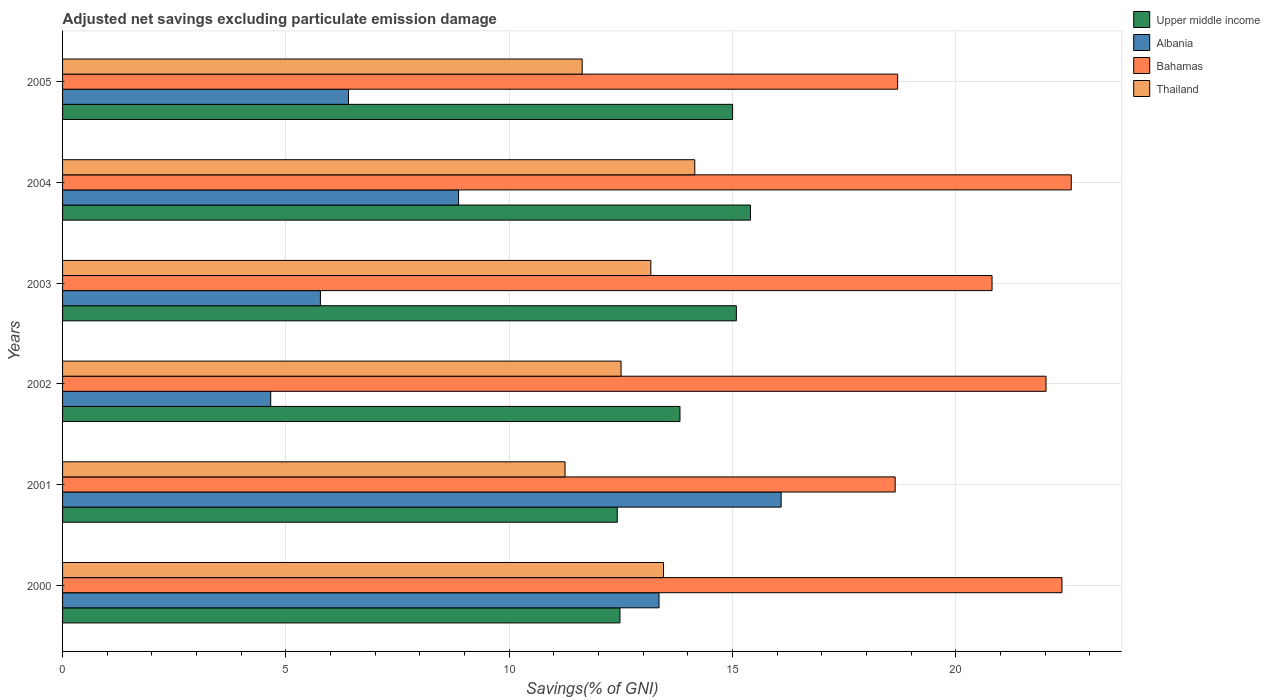How many groups of bars are there?
Offer a terse response. 6. How many bars are there on the 3rd tick from the top?
Ensure brevity in your answer.  4. What is the adjusted net savings in Upper middle income in 2002?
Your response must be concise. 13.82. Across all years, what is the maximum adjusted net savings in Thailand?
Provide a short and direct response. 14.16. Across all years, what is the minimum adjusted net savings in Upper middle income?
Give a very brief answer. 12.42. In which year was the adjusted net savings in Upper middle income maximum?
Your answer should be compact. 2004. What is the total adjusted net savings in Bahamas in the graph?
Give a very brief answer. 125.13. What is the difference between the adjusted net savings in Albania in 2000 and that in 2005?
Provide a succinct answer. 6.95. What is the difference between the adjusted net savings in Bahamas in 2000 and the adjusted net savings in Albania in 2002?
Give a very brief answer. 17.72. What is the average adjusted net savings in Bahamas per year?
Your answer should be compact. 20.86. In the year 2002, what is the difference between the adjusted net savings in Bahamas and adjusted net savings in Thailand?
Offer a terse response. 9.51. What is the ratio of the adjusted net savings in Thailand in 2002 to that in 2004?
Your answer should be compact. 0.88. Is the adjusted net savings in Thailand in 2000 less than that in 2003?
Make the answer very short. No. Is the difference between the adjusted net savings in Bahamas in 2001 and 2005 greater than the difference between the adjusted net savings in Thailand in 2001 and 2005?
Give a very brief answer. Yes. What is the difference between the highest and the second highest adjusted net savings in Thailand?
Ensure brevity in your answer.  0.7. What is the difference between the highest and the lowest adjusted net savings in Albania?
Give a very brief answer. 11.43. What does the 2nd bar from the top in 2003 represents?
Your response must be concise. Bahamas. What does the 3rd bar from the bottom in 2003 represents?
Offer a terse response. Bahamas. How many years are there in the graph?
Your answer should be very brief. 6. How many legend labels are there?
Offer a very short reply. 4. What is the title of the graph?
Keep it short and to the point. Adjusted net savings excluding particulate emission damage. What is the label or title of the X-axis?
Ensure brevity in your answer.  Savings(% of GNI). What is the label or title of the Y-axis?
Keep it short and to the point. Years. What is the Savings(% of GNI) in Upper middle income in 2000?
Make the answer very short. 12.48. What is the Savings(% of GNI) of Albania in 2000?
Your response must be concise. 13.35. What is the Savings(% of GNI) of Bahamas in 2000?
Give a very brief answer. 22.38. What is the Savings(% of GNI) of Thailand in 2000?
Make the answer very short. 13.46. What is the Savings(% of GNI) of Upper middle income in 2001?
Make the answer very short. 12.42. What is the Savings(% of GNI) in Albania in 2001?
Keep it short and to the point. 16.09. What is the Savings(% of GNI) in Bahamas in 2001?
Your response must be concise. 18.64. What is the Savings(% of GNI) of Thailand in 2001?
Your answer should be very brief. 11.25. What is the Savings(% of GNI) of Upper middle income in 2002?
Make the answer very short. 13.82. What is the Savings(% of GNI) in Albania in 2002?
Provide a succinct answer. 4.66. What is the Savings(% of GNI) of Bahamas in 2002?
Keep it short and to the point. 22.02. What is the Savings(% of GNI) of Thailand in 2002?
Offer a very short reply. 12.51. What is the Savings(% of GNI) in Upper middle income in 2003?
Offer a very short reply. 15.09. What is the Savings(% of GNI) of Albania in 2003?
Keep it short and to the point. 5.77. What is the Savings(% of GNI) of Bahamas in 2003?
Ensure brevity in your answer.  20.81. What is the Savings(% of GNI) of Thailand in 2003?
Your answer should be compact. 13.17. What is the Savings(% of GNI) in Upper middle income in 2004?
Make the answer very short. 15.4. What is the Savings(% of GNI) in Albania in 2004?
Provide a succinct answer. 8.87. What is the Savings(% of GNI) of Bahamas in 2004?
Give a very brief answer. 22.58. What is the Savings(% of GNI) in Thailand in 2004?
Your response must be concise. 14.16. What is the Savings(% of GNI) in Upper middle income in 2005?
Provide a short and direct response. 15. What is the Savings(% of GNI) of Albania in 2005?
Make the answer very short. 6.4. What is the Savings(% of GNI) of Bahamas in 2005?
Keep it short and to the point. 18.7. What is the Savings(% of GNI) of Thailand in 2005?
Your response must be concise. 11.63. Across all years, what is the maximum Savings(% of GNI) in Upper middle income?
Offer a terse response. 15.4. Across all years, what is the maximum Savings(% of GNI) in Albania?
Give a very brief answer. 16.09. Across all years, what is the maximum Savings(% of GNI) in Bahamas?
Ensure brevity in your answer.  22.58. Across all years, what is the maximum Savings(% of GNI) of Thailand?
Your response must be concise. 14.16. Across all years, what is the minimum Savings(% of GNI) of Upper middle income?
Provide a succinct answer. 12.42. Across all years, what is the minimum Savings(% of GNI) in Albania?
Give a very brief answer. 4.66. Across all years, what is the minimum Savings(% of GNI) in Bahamas?
Provide a succinct answer. 18.64. Across all years, what is the minimum Savings(% of GNI) in Thailand?
Provide a short and direct response. 11.25. What is the total Savings(% of GNI) of Upper middle income in the graph?
Provide a succinct answer. 84.21. What is the total Savings(% of GNI) in Albania in the graph?
Make the answer very short. 55.15. What is the total Savings(% of GNI) of Bahamas in the graph?
Give a very brief answer. 125.13. What is the total Savings(% of GNI) of Thailand in the graph?
Offer a very short reply. 76.17. What is the difference between the Savings(% of GNI) in Upper middle income in 2000 and that in 2001?
Make the answer very short. 0.06. What is the difference between the Savings(% of GNI) of Albania in 2000 and that in 2001?
Your answer should be compact. -2.73. What is the difference between the Savings(% of GNI) in Bahamas in 2000 and that in 2001?
Ensure brevity in your answer.  3.73. What is the difference between the Savings(% of GNI) of Thailand in 2000 and that in 2001?
Ensure brevity in your answer.  2.21. What is the difference between the Savings(% of GNI) of Upper middle income in 2000 and that in 2002?
Ensure brevity in your answer.  -1.34. What is the difference between the Savings(% of GNI) in Albania in 2000 and that in 2002?
Your answer should be very brief. 8.69. What is the difference between the Savings(% of GNI) in Bahamas in 2000 and that in 2002?
Your answer should be compact. 0.36. What is the difference between the Savings(% of GNI) of Thailand in 2000 and that in 2002?
Ensure brevity in your answer.  0.95. What is the difference between the Savings(% of GNI) in Upper middle income in 2000 and that in 2003?
Provide a succinct answer. -2.61. What is the difference between the Savings(% of GNI) in Albania in 2000 and that in 2003?
Make the answer very short. 7.58. What is the difference between the Savings(% of GNI) of Bahamas in 2000 and that in 2003?
Your answer should be compact. 1.57. What is the difference between the Savings(% of GNI) of Thailand in 2000 and that in 2003?
Your answer should be very brief. 0.28. What is the difference between the Savings(% of GNI) of Upper middle income in 2000 and that in 2004?
Provide a succinct answer. -2.92. What is the difference between the Savings(% of GNI) in Albania in 2000 and that in 2004?
Ensure brevity in your answer.  4.49. What is the difference between the Savings(% of GNI) of Bahamas in 2000 and that in 2004?
Keep it short and to the point. -0.21. What is the difference between the Savings(% of GNI) in Thailand in 2000 and that in 2004?
Offer a terse response. -0.7. What is the difference between the Savings(% of GNI) of Upper middle income in 2000 and that in 2005?
Provide a succinct answer. -2.52. What is the difference between the Savings(% of GNI) in Albania in 2000 and that in 2005?
Your answer should be very brief. 6.95. What is the difference between the Savings(% of GNI) in Bahamas in 2000 and that in 2005?
Give a very brief answer. 3.68. What is the difference between the Savings(% of GNI) of Thailand in 2000 and that in 2005?
Your answer should be very brief. 1.82. What is the difference between the Savings(% of GNI) of Upper middle income in 2001 and that in 2002?
Your answer should be very brief. -1.4. What is the difference between the Savings(% of GNI) in Albania in 2001 and that in 2002?
Ensure brevity in your answer.  11.43. What is the difference between the Savings(% of GNI) of Bahamas in 2001 and that in 2002?
Provide a succinct answer. -3.38. What is the difference between the Savings(% of GNI) of Thailand in 2001 and that in 2002?
Offer a terse response. -1.26. What is the difference between the Savings(% of GNI) of Upper middle income in 2001 and that in 2003?
Offer a very short reply. -2.67. What is the difference between the Savings(% of GNI) in Albania in 2001 and that in 2003?
Ensure brevity in your answer.  10.32. What is the difference between the Savings(% of GNI) in Bahamas in 2001 and that in 2003?
Provide a succinct answer. -2.17. What is the difference between the Savings(% of GNI) in Thailand in 2001 and that in 2003?
Your answer should be very brief. -1.92. What is the difference between the Savings(% of GNI) of Upper middle income in 2001 and that in 2004?
Your answer should be very brief. -2.98. What is the difference between the Savings(% of GNI) in Albania in 2001 and that in 2004?
Your response must be concise. 7.22. What is the difference between the Savings(% of GNI) in Bahamas in 2001 and that in 2004?
Your response must be concise. -3.94. What is the difference between the Savings(% of GNI) of Thailand in 2001 and that in 2004?
Your response must be concise. -2.9. What is the difference between the Savings(% of GNI) in Upper middle income in 2001 and that in 2005?
Make the answer very short. -2.58. What is the difference between the Savings(% of GNI) in Albania in 2001 and that in 2005?
Your answer should be compact. 9.69. What is the difference between the Savings(% of GNI) in Bahamas in 2001 and that in 2005?
Give a very brief answer. -0.06. What is the difference between the Savings(% of GNI) in Thailand in 2001 and that in 2005?
Ensure brevity in your answer.  -0.38. What is the difference between the Savings(% of GNI) in Upper middle income in 2002 and that in 2003?
Make the answer very short. -1.26. What is the difference between the Savings(% of GNI) in Albania in 2002 and that in 2003?
Your response must be concise. -1.11. What is the difference between the Savings(% of GNI) in Bahamas in 2002 and that in 2003?
Ensure brevity in your answer.  1.21. What is the difference between the Savings(% of GNI) in Thailand in 2002 and that in 2003?
Make the answer very short. -0.67. What is the difference between the Savings(% of GNI) of Upper middle income in 2002 and that in 2004?
Offer a terse response. -1.58. What is the difference between the Savings(% of GNI) in Albania in 2002 and that in 2004?
Your answer should be compact. -4.21. What is the difference between the Savings(% of GNI) of Bahamas in 2002 and that in 2004?
Keep it short and to the point. -0.56. What is the difference between the Savings(% of GNI) in Thailand in 2002 and that in 2004?
Give a very brief answer. -1.65. What is the difference between the Savings(% of GNI) in Upper middle income in 2002 and that in 2005?
Give a very brief answer. -1.18. What is the difference between the Savings(% of GNI) in Albania in 2002 and that in 2005?
Your answer should be compact. -1.74. What is the difference between the Savings(% of GNI) of Bahamas in 2002 and that in 2005?
Make the answer very short. 3.32. What is the difference between the Savings(% of GNI) in Thailand in 2002 and that in 2005?
Ensure brevity in your answer.  0.87. What is the difference between the Savings(% of GNI) in Upper middle income in 2003 and that in 2004?
Provide a short and direct response. -0.32. What is the difference between the Savings(% of GNI) in Albania in 2003 and that in 2004?
Keep it short and to the point. -3.09. What is the difference between the Savings(% of GNI) in Bahamas in 2003 and that in 2004?
Provide a succinct answer. -1.77. What is the difference between the Savings(% of GNI) of Thailand in 2003 and that in 2004?
Offer a terse response. -0.98. What is the difference between the Savings(% of GNI) in Upper middle income in 2003 and that in 2005?
Provide a succinct answer. 0.08. What is the difference between the Savings(% of GNI) in Albania in 2003 and that in 2005?
Offer a terse response. -0.63. What is the difference between the Savings(% of GNI) of Bahamas in 2003 and that in 2005?
Provide a short and direct response. 2.11. What is the difference between the Savings(% of GNI) of Thailand in 2003 and that in 2005?
Your answer should be very brief. 1.54. What is the difference between the Savings(% of GNI) in Upper middle income in 2004 and that in 2005?
Your answer should be compact. 0.4. What is the difference between the Savings(% of GNI) in Albania in 2004 and that in 2005?
Make the answer very short. 2.47. What is the difference between the Savings(% of GNI) of Bahamas in 2004 and that in 2005?
Keep it short and to the point. 3.89. What is the difference between the Savings(% of GNI) in Thailand in 2004 and that in 2005?
Give a very brief answer. 2.52. What is the difference between the Savings(% of GNI) in Upper middle income in 2000 and the Savings(% of GNI) in Albania in 2001?
Your response must be concise. -3.61. What is the difference between the Savings(% of GNI) of Upper middle income in 2000 and the Savings(% of GNI) of Bahamas in 2001?
Your response must be concise. -6.16. What is the difference between the Savings(% of GNI) of Upper middle income in 2000 and the Savings(% of GNI) of Thailand in 2001?
Offer a terse response. 1.23. What is the difference between the Savings(% of GNI) in Albania in 2000 and the Savings(% of GNI) in Bahamas in 2001?
Provide a succinct answer. -5.29. What is the difference between the Savings(% of GNI) in Albania in 2000 and the Savings(% of GNI) in Thailand in 2001?
Give a very brief answer. 2.1. What is the difference between the Savings(% of GNI) in Bahamas in 2000 and the Savings(% of GNI) in Thailand in 2001?
Keep it short and to the point. 11.13. What is the difference between the Savings(% of GNI) in Upper middle income in 2000 and the Savings(% of GNI) in Albania in 2002?
Keep it short and to the point. 7.82. What is the difference between the Savings(% of GNI) in Upper middle income in 2000 and the Savings(% of GNI) in Bahamas in 2002?
Make the answer very short. -9.54. What is the difference between the Savings(% of GNI) of Upper middle income in 2000 and the Savings(% of GNI) of Thailand in 2002?
Ensure brevity in your answer.  -0.03. What is the difference between the Savings(% of GNI) in Albania in 2000 and the Savings(% of GNI) in Bahamas in 2002?
Your answer should be very brief. -8.67. What is the difference between the Savings(% of GNI) in Albania in 2000 and the Savings(% of GNI) in Thailand in 2002?
Keep it short and to the point. 0.85. What is the difference between the Savings(% of GNI) in Bahamas in 2000 and the Savings(% of GNI) in Thailand in 2002?
Your response must be concise. 9.87. What is the difference between the Savings(% of GNI) of Upper middle income in 2000 and the Savings(% of GNI) of Albania in 2003?
Provide a short and direct response. 6.71. What is the difference between the Savings(% of GNI) of Upper middle income in 2000 and the Savings(% of GNI) of Bahamas in 2003?
Ensure brevity in your answer.  -8.33. What is the difference between the Savings(% of GNI) of Upper middle income in 2000 and the Savings(% of GNI) of Thailand in 2003?
Ensure brevity in your answer.  -0.69. What is the difference between the Savings(% of GNI) in Albania in 2000 and the Savings(% of GNI) in Bahamas in 2003?
Your answer should be very brief. -7.46. What is the difference between the Savings(% of GNI) of Albania in 2000 and the Savings(% of GNI) of Thailand in 2003?
Make the answer very short. 0.18. What is the difference between the Savings(% of GNI) in Bahamas in 2000 and the Savings(% of GNI) in Thailand in 2003?
Give a very brief answer. 9.21. What is the difference between the Savings(% of GNI) in Upper middle income in 2000 and the Savings(% of GNI) in Albania in 2004?
Your answer should be compact. 3.61. What is the difference between the Savings(% of GNI) of Upper middle income in 2000 and the Savings(% of GNI) of Bahamas in 2004?
Provide a short and direct response. -10.11. What is the difference between the Savings(% of GNI) of Upper middle income in 2000 and the Savings(% of GNI) of Thailand in 2004?
Give a very brief answer. -1.68. What is the difference between the Savings(% of GNI) of Albania in 2000 and the Savings(% of GNI) of Bahamas in 2004?
Offer a terse response. -9.23. What is the difference between the Savings(% of GNI) in Albania in 2000 and the Savings(% of GNI) in Thailand in 2004?
Make the answer very short. -0.8. What is the difference between the Savings(% of GNI) of Bahamas in 2000 and the Savings(% of GNI) of Thailand in 2004?
Your answer should be very brief. 8.22. What is the difference between the Savings(% of GNI) in Upper middle income in 2000 and the Savings(% of GNI) in Albania in 2005?
Keep it short and to the point. 6.08. What is the difference between the Savings(% of GNI) in Upper middle income in 2000 and the Savings(% of GNI) in Bahamas in 2005?
Your answer should be compact. -6.22. What is the difference between the Savings(% of GNI) of Upper middle income in 2000 and the Savings(% of GNI) of Thailand in 2005?
Give a very brief answer. 0.85. What is the difference between the Savings(% of GNI) in Albania in 2000 and the Savings(% of GNI) in Bahamas in 2005?
Offer a terse response. -5.34. What is the difference between the Savings(% of GNI) in Albania in 2000 and the Savings(% of GNI) in Thailand in 2005?
Your answer should be compact. 1.72. What is the difference between the Savings(% of GNI) of Bahamas in 2000 and the Savings(% of GNI) of Thailand in 2005?
Keep it short and to the point. 10.74. What is the difference between the Savings(% of GNI) of Upper middle income in 2001 and the Savings(% of GNI) of Albania in 2002?
Offer a terse response. 7.76. What is the difference between the Savings(% of GNI) of Upper middle income in 2001 and the Savings(% of GNI) of Bahamas in 2002?
Keep it short and to the point. -9.6. What is the difference between the Savings(% of GNI) of Upper middle income in 2001 and the Savings(% of GNI) of Thailand in 2002?
Give a very brief answer. -0.09. What is the difference between the Savings(% of GNI) in Albania in 2001 and the Savings(% of GNI) in Bahamas in 2002?
Give a very brief answer. -5.93. What is the difference between the Savings(% of GNI) in Albania in 2001 and the Savings(% of GNI) in Thailand in 2002?
Offer a very short reply. 3.58. What is the difference between the Savings(% of GNI) in Bahamas in 2001 and the Savings(% of GNI) in Thailand in 2002?
Give a very brief answer. 6.14. What is the difference between the Savings(% of GNI) in Upper middle income in 2001 and the Savings(% of GNI) in Albania in 2003?
Your answer should be compact. 6.65. What is the difference between the Savings(% of GNI) of Upper middle income in 2001 and the Savings(% of GNI) of Bahamas in 2003?
Give a very brief answer. -8.39. What is the difference between the Savings(% of GNI) of Upper middle income in 2001 and the Savings(% of GNI) of Thailand in 2003?
Your answer should be very brief. -0.75. What is the difference between the Savings(% of GNI) of Albania in 2001 and the Savings(% of GNI) of Bahamas in 2003?
Your response must be concise. -4.72. What is the difference between the Savings(% of GNI) in Albania in 2001 and the Savings(% of GNI) in Thailand in 2003?
Provide a short and direct response. 2.92. What is the difference between the Savings(% of GNI) in Bahamas in 2001 and the Savings(% of GNI) in Thailand in 2003?
Offer a terse response. 5.47. What is the difference between the Savings(% of GNI) in Upper middle income in 2001 and the Savings(% of GNI) in Albania in 2004?
Make the answer very short. 3.55. What is the difference between the Savings(% of GNI) in Upper middle income in 2001 and the Savings(% of GNI) in Bahamas in 2004?
Your answer should be compact. -10.17. What is the difference between the Savings(% of GNI) of Upper middle income in 2001 and the Savings(% of GNI) of Thailand in 2004?
Make the answer very short. -1.74. What is the difference between the Savings(% of GNI) of Albania in 2001 and the Savings(% of GNI) of Bahamas in 2004?
Your answer should be very brief. -6.5. What is the difference between the Savings(% of GNI) of Albania in 2001 and the Savings(% of GNI) of Thailand in 2004?
Ensure brevity in your answer.  1.93. What is the difference between the Savings(% of GNI) in Bahamas in 2001 and the Savings(% of GNI) in Thailand in 2004?
Your answer should be compact. 4.49. What is the difference between the Savings(% of GNI) of Upper middle income in 2001 and the Savings(% of GNI) of Albania in 2005?
Keep it short and to the point. 6.02. What is the difference between the Savings(% of GNI) in Upper middle income in 2001 and the Savings(% of GNI) in Bahamas in 2005?
Provide a short and direct response. -6.28. What is the difference between the Savings(% of GNI) of Upper middle income in 2001 and the Savings(% of GNI) of Thailand in 2005?
Your answer should be very brief. 0.79. What is the difference between the Savings(% of GNI) of Albania in 2001 and the Savings(% of GNI) of Bahamas in 2005?
Your answer should be compact. -2.61. What is the difference between the Savings(% of GNI) in Albania in 2001 and the Savings(% of GNI) in Thailand in 2005?
Offer a very short reply. 4.45. What is the difference between the Savings(% of GNI) of Bahamas in 2001 and the Savings(% of GNI) of Thailand in 2005?
Give a very brief answer. 7.01. What is the difference between the Savings(% of GNI) of Upper middle income in 2002 and the Savings(% of GNI) of Albania in 2003?
Ensure brevity in your answer.  8.05. What is the difference between the Savings(% of GNI) of Upper middle income in 2002 and the Savings(% of GNI) of Bahamas in 2003?
Keep it short and to the point. -6.99. What is the difference between the Savings(% of GNI) of Upper middle income in 2002 and the Savings(% of GNI) of Thailand in 2003?
Your answer should be compact. 0.65. What is the difference between the Savings(% of GNI) of Albania in 2002 and the Savings(% of GNI) of Bahamas in 2003?
Your response must be concise. -16.15. What is the difference between the Savings(% of GNI) in Albania in 2002 and the Savings(% of GNI) in Thailand in 2003?
Provide a succinct answer. -8.51. What is the difference between the Savings(% of GNI) of Bahamas in 2002 and the Savings(% of GNI) of Thailand in 2003?
Make the answer very short. 8.85. What is the difference between the Savings(% of GNI) of Upper middle income in 2002 and the Savings(% of GNI) of Albania in 2004?
Provide a short and direct response. 4.96. What is the difference between the Savings(% of GNI) in Upper middle income in 2002 and the Savings(% of GNI) in Bahamas in 2004?
Your response must be concise. -8.76. What is the difference between the Savings(% of GNI) of Upper middle income in 2002 and the Savings(% of GNI) of Thailand in 2004?
Offer a terse response. -0.33. What is the difference between the Savings(% of GNI) in Albania in 2002 and the Savings(% of GNI) in Bahamas in 2004?
Ensure brevity in your answer.  -17.92. What is the difference between the Savings(% of GNI) of Albania in 2002 and the Savings(% of GNI) of Thailand in 2004?
Your response must be concise. -9.49. What is the difference between the Savings(% of GNI) of Bahamas in 2002 and the Savings(% of GNI) of Thailand in 2004?
Ensure brevity in your answer.  7.87. What is the difference between the Savings(% of GNI) in Upper middle income in 2002 and the Savings(% of GNI) in Albania in 2005?
Give a very brief answer. 7.42. What is the difference between the Savings(% of GNI) of Upper middle income in 2002 and the Savings(% of GNI) of Bahamas in 2005?
Your answer should be compact. -4.87. What is the difference between the Savings(% of GNI) of Upper middle income in 2002 and the Savings(% of GNI) of Thailand in 2005?
Keep it short and to the point. 2.19. What is the difference between the Savings(% of GNI) in Albania in 2002 and the Savings(% of GNI) in Bahamas in 2005?
Your response must be concise. -14.04. What is the difference between the Savings(% of GNI) in Albania in 2002 and the Savings(% of GNI) in Thailand in 2005?
Your response must be concise. -6.97. What is the difference between the Savings(% of GNI) in Bahamas in 2002 and the Savings(% of GNI) in Thailand in 2005?
Your response must be concise. 10.39. What is the difference between the Savings(% of GNI) in Upper middle income in 2003 and the Savings(% of GNI) in Albania in 2004?
Your answer should be very brief. 6.22. What is the difference between the Savings(% of GNI) of Upper middle income in 2003 and the Savings(% of GNI) of Bahamas in 2004?
Provide a short and direct response. -7.5. What is the difference between the Savings(% of GNI) in Upper middle income in 2003 and the Savings(% of GNI) in Thailand in 2004?
Offer a very short reply. 0.93. What is the difference between the Savings(% of GNI) of Albania in 2003 and the Savings(% of GNI) of Bahamas in 2004?
Give a very brief answer. -16.81. What is the difference between the Savings(% of GNI) of Albania in 2003 and the Savings(% of GNI) of Thailand in 2004?
Your response must be concise. -8.38. What is the difference between the Savings(% of GNI) in Bahamas in 2003 and the Savings(% of GNI) in Thailand in 2004?
Provide a succinct answer. 6.66. What is the difference between the Savings(% of GNI) of Upper middle income in 2003 and the Savings(% of GNI) of Albania in 2005?
Ensure brevity in your answer.  8.69. What is the difference between the Savings(% of GNI) in Upper middle income in 2003 and the Savings(% of GNI) in Bahamas in 2005?
Offer a very short reply. -3.61. What is the difference between the Savings(% of GNI) of Upper middle income in 2003 and the Savings(% of GNI) of Thailand in 2005?
Your response must be concise. 3.45. What is the difference between the Savings(% of GNI) in Albania in 2003 and the Savings(% of GNI) in Bahamas in 2005?
Provide a succinct answer. -12.92. What is the difference between the Savings(% of GNI) of Albania in 2003 and the Savings(% of GNI) of Thailand in 2005?
Your response must be concise. -5.86. What is the difference between the Savings(% of GNI) of Bahamas in 2003 and the Savings(% of GNI) of Thailand in 2005?
Make the answer very short. 9.18. What is the difference between the Savings(% of GNI) of Upper middle income in 2004 and the Savings(% of GNI) of Albania in 2005?
Offer a very short reply. 9. What is the difference between the Savings(% of GNI) of Upper middle income in 2004 and the Savings(% of GNI) of Bahamas in 2005?
Your answer should be compact. -3.3. What is the difference between the Savings(% of GNI) of Upper middle income in 2004 and the Savings(% of GNI) of Thailand in 2005?
Give a very brief answer. 3.77. What is the difference between the Savings(% of GNI) of Albania in 2004 and the Savings(% of GNI) of Bahamas in 2005?
Your response must be concise. -9.83. What is the difference between the Savings(% of GNI) in Albania in 2004 and the Savings(% of GNI) in Thailand in 2005?
Keep it short and to the point. -2.77. What is the difference between the Savings(% of GNI) of Bahamas in 2004 and the Savings(% of GNI) of Thailand in 2005?
Offer a terse response. 10.95. What is the average Savings(% of GNI) in Upper middle income per year?
Offer a very short reply. 14.04. What is the average Savings(% of GNI) in Albania per year?
Ensure brevity in your answer.  9.19. What is the average Savings(% of GNI) in Bahamas per year?
Offer a very short reply. 20.86. What is the average Savings(% of GNI) in Thailand per year?
Provide a short and direct response. 12.7. In the year 2000, what is the difference between the Savings(% of GNI) of Upper middle income and Savings(% of GNI) of Albania?
Your answer should be very brief. -0.87. In the year 2000, what is the difference between the Savings(% of GNI) in Upper middle income and Savings(% of GNI) in Bahamas?
Offer a terse response. -9.9. In the year 2000, what is the difference between the Savings(% of GNI) in Upper middle income and Savings(% of GNI) in Thailand?
Your response must be concise. -0.98. In the year 2000, what is the difference between the Savings(% of GNI) of Albania and Savings(% of GNI) of Bahamas?
Make the answer very short. -9.02. In the year 2000, what is the difference between the Savings(% of GNI) of Albania and Savings(% of GNI) of Thailand?
Provide a short and direct response. -0.1. In the year 2000, what is the difference between the Savings(% of GNI) in Bahamas and Savings(% of GNI) in Thailand?
Provide a short and direct response. 8.92. In the year 2001, what is the difference between the Savings(% of GNI) of Upper middle income and Savings(% of GNI) of Albania?
Your response must be concise. -3.67. In the year 2001, what is the difference between the Savings(% of GNI) in Upper middle income and Savings(% of GNI) in Bahamas?
Provide a short and direct response. -6.22. In the year 2001, what is the difference between the Savings(% of GNI) in Upper middle income and Savings(% of GNI) in Thailand?
Make the answer very short. 1.17. In the year 2001, what is the difference between the Savings(% of GNI) in Albania and Savings(% of GNI) in Bahamas?
Provide a succinct answer. -2.55. In the year 2001, what is the difference between the Savings(% of GNI) of Albania and Savings(% of GNI) of Thailand?
Your answer should be compact. 4.84. In the year 2001, what is the difference between the Savings(% of GNI) in Bahamas and Savings(% of GNI) in Thailand?
Provide a succinct answer. 7.39. In the year 2002, what is the difference between the Savings(% of GNI) in Upper middle income and Savings(% of GNI) in Albania?
Ensure brevity in your answer.  9.16. In the year 2002, what is the difference between the Savings(% of GNI) of Upper middle income and Savings(% of GNI) of Bahamas?
Keep it short and to the point. -8.2. In the year 2002, what is the difference between the Savings(% of GNI) of Upper middle income and Savings(% of GNI) of Thailand?
Offer a very short reply. 1.32. In the year 2002, what is the difference between the Savings(% of GNI) in Albania and Savings(% of GNI) in Bahamas?
Ensure brevity in your answer.  -17.36. In the year 2002, what is the difference between the Savings(% of GNI) in Albania and Savings(% of GNI) in Thailand?
Provide a succinct answer. -7.85. In the year 2002, what is the difference between the Savings(% of GNI) in Bahamas and Savings(% of GNI) in Thailand?
Your answer should be compact. 9.51. In the year 2003, what is the difference between the Savings(% of GNI) of Upper middle income and Savings(% of GNI) of Albania?
Provide a short and direct response. 9.31. In the year 2003, what is the difference between the Savings(% of GNI) in Upper middle income and Savings(% of GNI) in Bahamas?
Your answer should be compact. -5.72. In the year 2003, what is the difference between the Savings(% of GNI) in Upper middle income and Savings(% of GNI) in Thailand?
Your answer should be compact. 1.92. In the year 2003, what is the difference between the Savings(% of GNI) of Albania and Savings(% of GNI) of Bahamas?
Provide a short and direct response. -15.04. In the year 2003, what is the difference between the Savings(% of GNI) of Albania and Savings(% of GNI) of Thailand?
Your answer should be compact. -7.4. In the year 2003, what is the difference between the Savings(% of GNI) in Bahamas and Savings(% of GNI) in Thailand?
Provide a succinct answer. 7.64. In the year 2004, what is the difference between the Savings(% of GNI) in Upper middle income and Savings(% of GNI) in Albania?
Your response must be concise. 6.54. In the year 2004, what is the difference between the Savings(% of GNI) of Upper middle income and Savings(% of GNI) of Bahamas?
Offer a very short reply. -7.18. In the year 2004, what is the difference between the Savings(% of GNI) in Upper middle income and Savings(% of GNI) in Thailand?
Offer a terse response. 1.25. In the year 2004, what is the difference between the Savings(% of GNI) of Albania and Savings(% of GNI) of Bahamas?
Give a very brief answer. -13.72. In the year 2004, what is the difference between the Savings(% of GNI) in Albania and Savings(% of GNI) in Thailand?
Give a very brief answer. -5.29. In the year 2004, what is the difference between the Savings(% of GNI) of Bahamas and Savings(% of GNI) of Thailand?
Make the answer very short. 8.43. In the year 2005, what is the difference between the Savings(% of GNI) in Upper middle income and Savings(% of GNI) in Albania?
Provide a succinct answer. 8.6. In the year 2005, what is the difference between the Savings(% of GNI) of Upper middle income and Savings(% of GNI) of Bahamas?
Provide a short and direct response. -3.7. In the year 2005, what is the difference between the Savings(% of GNI) in Upper middle income and Savings(% of GNI) in Thailand?
Provide a succinct answer. 3.37. In the year 2005, what is the difference between the Savings(% of GNI) of Albania and Savings(% of GNI) of Bahamas?
Offer a very short reply. -12.3. In the year 2005, what is the difference between the Savings(% of GNI) of Albania and Savings(% of GNI) of Thailand?
Make the answer very short. -5.23. In the year 2005, what is the difference between the Savings(% of GNI) in Bahamas and Savings(% of GNI) in Thailand?
Offer a very short reply. 7.06. What is the ratio of the Savings(% of GNI) in Upper middle income in 2000 to that in 2001?
Keep it short and to the point. 1. What is the ratio of the Savings(% of GNI) of Albania in 2000 to that in 2001?
Your response must be concise. 0.83. What is the ratio of the Savings(% of GNI) in Bahamas in 2000 to that in 2001?
Provide a succinct answer. 1.2. What is the ratio of the Savings(% of GNI) of Thailand in 2000 to that in 2001?
Make the answer very short. 1.2. What is the ratio of the Savings(% of GNI) in Upper middle income in 2000 to that in 2002?
Your response must be concise. 0.9. What is the ratio of the Savings(% of GNI) in Albania in 2000 to that in 2002?
Offer a very short reply. 2.87. What is the ratio of the Savings(% of GNI) of Bahamas in 2000 to that in 2002?
Your answer should be compact. 1.02. What is the ratio of the Savings(% of GNI) of Thailand in 2000 to that in 2002?
Ensure brevity in your answer.  1.08. What is the ratio of the Savings(% of GNI) of Upper middle income in 2000 to that in 2003?
Offer a terse response. 0.83. What is the ratio of the Savings(% of GNI) in Albania in 2000 to that in 2003?
Give a very brief answer. 2.31. What is the ratio of the Savings(% of GNI) of Bahamas in 2000 to that in 2003?
Your response must be concise. 1.08. What is the ratio of the Savings(% of GNI) of Thailand in 2000 to that in 2003?
Offer a very short reply. 1.02. What is the ratio of the Savings(% of GNI) in Upper middle income in 2000 to that in 2004?
Offer a terse response. 0.81. What is the ratio of the Savings(% of GNI) of Albania in 2000 to that in 2004?
Your response must be concise. 1.51. What is the ratio of the Savings(% of GNI) in Bahamas in 2000 to that in 2004?
Your answer should be compact. 0.99. What is the ratio of the Savings(% of GNI) in Thailand in 2000 to that in 2004?
Offer a terse response. 0.95. What is the ratio of the Savings(% of GNI) of Upper middle income in 2000 to that in 2005?
Give a very brief answer. 0.83. What is the ratio of the Savings(% of GNI) in Albania in 2000 to that in 2005?
Your response must be concise. 2.09. What is the ratio of the Savings(% of GNI) in Bahamas in 2000 to that in 2005?
Your response must be concise. 1.2. What is the ratio of the Savings(% of GNI) of Thailand in 2000 to that in 2005?
Make the answer very short. 1.16. What is the ratio of the Savings(% of GNI) in Upper middle income in 2001 to that in 2002?
Offer a very short reply. 0.9. What is the ratio of the Savings(% of GNI) of Albania in 2001 to that in 2002?
Provide a short and direct response. 3.45. What is the ratio of the Savings(% of GNI) in Bahamas in 2001 to that in 2002?
Your response must be concise. 0.85. What is the ratio of the Savings(% of GNI) of Thailand in 2001 to that in 2002?
Provide a short and direct response. 0.9. What is the ratio of the Savings(% of GNI) in Upper middle income in 2001 to that in 2003?
Your answer should be compact. 0.82. What is the ratio of the Savings(% of GNI) of Albania in 2001 to that in 2003?
Make the answer very short. 2.79. What is the ratio of the Savings(% of GNI) in Bahamas in 2001 to that in 2003?
Ensure brevity in your answer.  0.9. What is the ratio of the Savings(% of GNI) of Thailand in 2001 to that in 2003?
Your answer should be very brief. 0.85. What is the ratio of the Savings(% of GNI) in Upper middle income in 2001 to that in 2004?
Provide a short and direct response. 0.81. What is the ratio of the Savings(% of GNI) of Albania in 2001 to that in 2004?
Offer a very short reply. 1.81. What is the ratio of the Savings(% of GNI) in Bahamas in 2001 to that in 2004?
Offer a very short reply. 0.83. What is the ratio of the Savings(% of GNI) of Thailand in 2001 to that in 2004?
Offer a very short reply. 0.79. What is the ratio of the Savings(% of GNI) of Upper middle income in 2001 to that in 2005?
Offer a very short reply. 0.83. What is the ratio of the Savings(% of GNI) in Albania in 2001 to that in 2005?
Your response must be concise. 2.51. What is the ratio of the Savings(% of GNI) of Bahamas in 2001 to that in 2005?
Offer a terse response. 1. What is the ratio of the Savings(% of GNI) in Thailand in 2001 to that in 2005?
Your response must be concise. 0.97. What is the ratio of the Savings(% of GNI) in Upper middle income in 2002 to that in 2003?
Make the answer very short. 0.92. What is the ratio of the Savings(% of GNI) of Albania in 2002 to that in 2003?
Your response must be concise. 0.81. What is the ratio of the Savings(% of GNI) of Bahamas in 2002 to that in 2003?
Your answer should be very brief. 1.06. What is the ratio of the Savings(% of GNI) in Thailand in 2002 to that in 2003?
Ensure brevity in your answer.  0.95. What is the ratio of the Savings(% of GNI) of Upper middle income in 2002 to that in 2004?
Give a very brief answer. 0.9. What is the ratio of the Savings(% of GNI) in Albania in 2002 to that in 2004?
Offer a terse response. 0.53. What is the ratio of the Savings(% of GNI) of Thailand in 2002 to that in 2004?
Ensure brevity in your answer.  0.88. What is the ratio of the Savings(% of GNI) of Upper middle income in 2002 to that in 2005?
Your answer should be compact. 0.92. What is the ratio of the Savings(% of GNI) in Albania in 2002 to that in 2005?
Keep it short and to the point. 0.73. What is the ratio of the Savings(% of GNI) of Bahamas in 2002 to that in 2005?
Provide a succinct answer. 1.18. What is the ratio of the Savings(% of GNI) of Thailand in 2002 to that in 2005?
Provide a short and direct response. 1.07. What is the ratio of the Savings(% of GNI) of Upper middle income in 2003 to that in 2004?
Give a very brief answer. 0.98. What is the ratio of the Savings(% of GNI) in Albania in 2003 to that in 2004?
Give a very brief answer. 0.65. What is the ratio of the Savings(% of GNI) of Bahamas in 2003 to that in 2004?
Keep it short and to the point. 0.92. What is the ratio of the Savings(% of GNI) in Thailand in 2003 to that in 2004?
Provide a short and direct response. 0.93. What is the ratio of the Savings(% of GNI) in Upper middle income in 2003 to that in 2005?
Your response must be concise. 1.01. What is the ratio of the Savings(% of GNI) of Albania in 2003 to that in 2005?
Offer a very short reply. 0.9. What is the ratio of the Savings(% of GNI) in Bahamas in 2003 to that in 2005?
Provide a short and direct response. 1.11. What is the ratio of the Savings(% of GNI) of Thailand in 2003 to that in 2005?
Keep it short and to the point. 1.13. What is the ratio of the Savings(% of GNI) of Upper middle income in 2004 to that in 2005?
Your answer should be very brief. 1.03. What is the ratio of the Savings(% of GNI) in Albania in 2004 to that in 2005?
Offer a very short reply. 1.39. What is the ratio of the Savings(% of GNI) of Bahamas in 2004 to that in 2005?
Offer a terse response. 1.21. What is the ratio of the Savings(% of GNI) in Thailand in 2004 to that in 2005?
Provide a short and direct response. 1.22. What is the difference between the highest and the second highest Savings(% of GNI) of Upper middle income?
Give a very brief answer. 0.32. What is the difference between the highest and the second highest Savings(% of GNI) of Albania?
Ensure brevity in your answer.  2.73. What is the difference between the highest and the second highest Savings(% of GNI) in Bahamas?
Keep it short and to the point. 0.21. What is the difference between the highest and the second highest Savings(% of GNI) of Thailand?
Your answer should be compact. 0.7. What is the difference between the highest and the lowest Savings(% of GNI) of Upper middle income?
Make the answer very short. 2.98. What is the difference between the highest and the lowest Savings(% of GNI) in Albania?
Make the answer very short. 11.43. What is the difference between the highest and the lowest Savings(% of GNI) of Bahamas?
Ensure brevity in your answer.  3.94. What is the difference between the highest and the lowest Savings(% of GNI) of Thailand?
Provide a succinct answer. 2.9. 